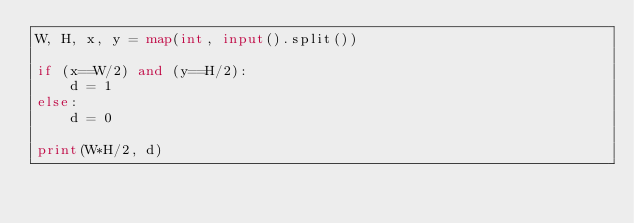<code> <loc_0><loc_0><loc_500><loc_500><_Python_>W, H, x, y = map(int, input().split())

if (x==W/2) and (y==H/2):
    d = 1
else:
    d = 0

print(W*H/2, d)</code> 